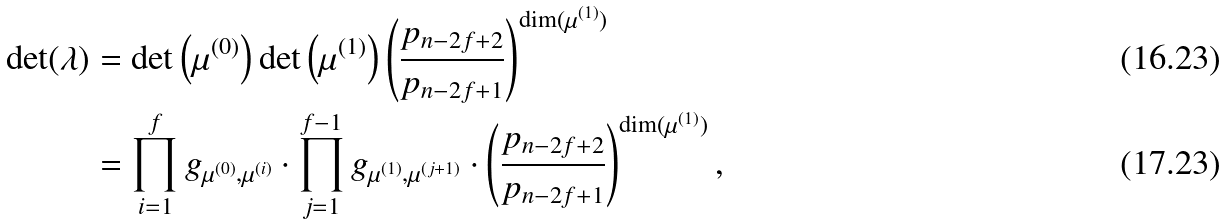<formula> <loc_0><loc_0><loc_500><loc_500>\det ( \lambda ) & = \det \left ( \mu ^ { ( 0 ) } \right ) \det \left ( \mu ^ { ( 1 ) } \right ) \left ( \frac { p _ { n - 2 f + 2 } } { p _ { n - 2 f + 1 } } \right ) ^ { \dim ( \mu ^ { ( 1 ) } ) } \\ & = \prod _ { i = 1 } ^ { f } g _ { \mu ^ { ( 0 ) } , \mu ^ { ( i ) } } \cdot \prod _ { j = 1 } ^ { f - 1 } g _ { \mu ^ { ( 1 ) } , \mu ^ { ( j + 1 ) } } \cdot \left ( \frac { p _ { n - 2 f + 2 } } { p _ { n - 2 f + 1 } } \right ) ^ { \dim ( \mu ^ { ( 1 ) } ) } ,</formula> 